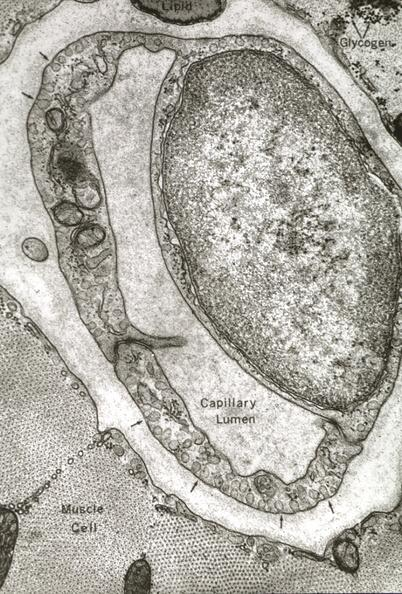what is present?
Answer the question using a single word or phrase. Cardiovascular 